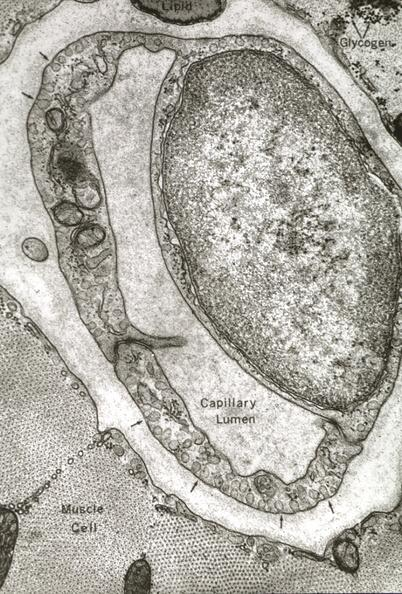what is present?
Answer the question using a single word or phrase. Cardiovascular 